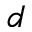Convert formula to latex. <formula><loc_0><loc_0><loc_500><loc_500>d</formula> 